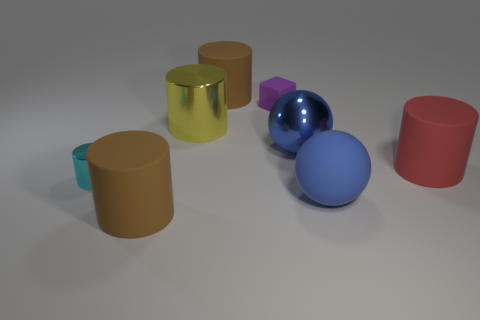Is there a big red rubber thing of the same shape as the blue rubber object?
Make the answer very short. No. There is another ball that is the same color as the metallic ball; what material is it?
Provide a short and direct response. Rubber. The large shiny thing on the right side of the tiny purple matte object has what shape?
Offer a terse response. Sphere. How many big cyan blocks are there?
Offer a terse response. 0. There is a big thing that is the same material as the big yellow cylinder; what is its color?
Your answer should be very brief. Blue. What number of tiny things are cyan things or rubber objects?
Make the answer very short. 2. There is a big shiny cylinder; how many tiny cylinders are right of it?
Make the answer very short. 0. The shiny object that is the same shape as the large blue matte object is what color?
Provide a short and direct response. Blue. What number of metal things are either yellow objects or brown cylinders?
Your response must be concise. 1. Are there any big blue shiny objects that are in front of the tiny thing to the left of the brown rubber cylinder in front of the small matte block?
Make the answer very short. No. 